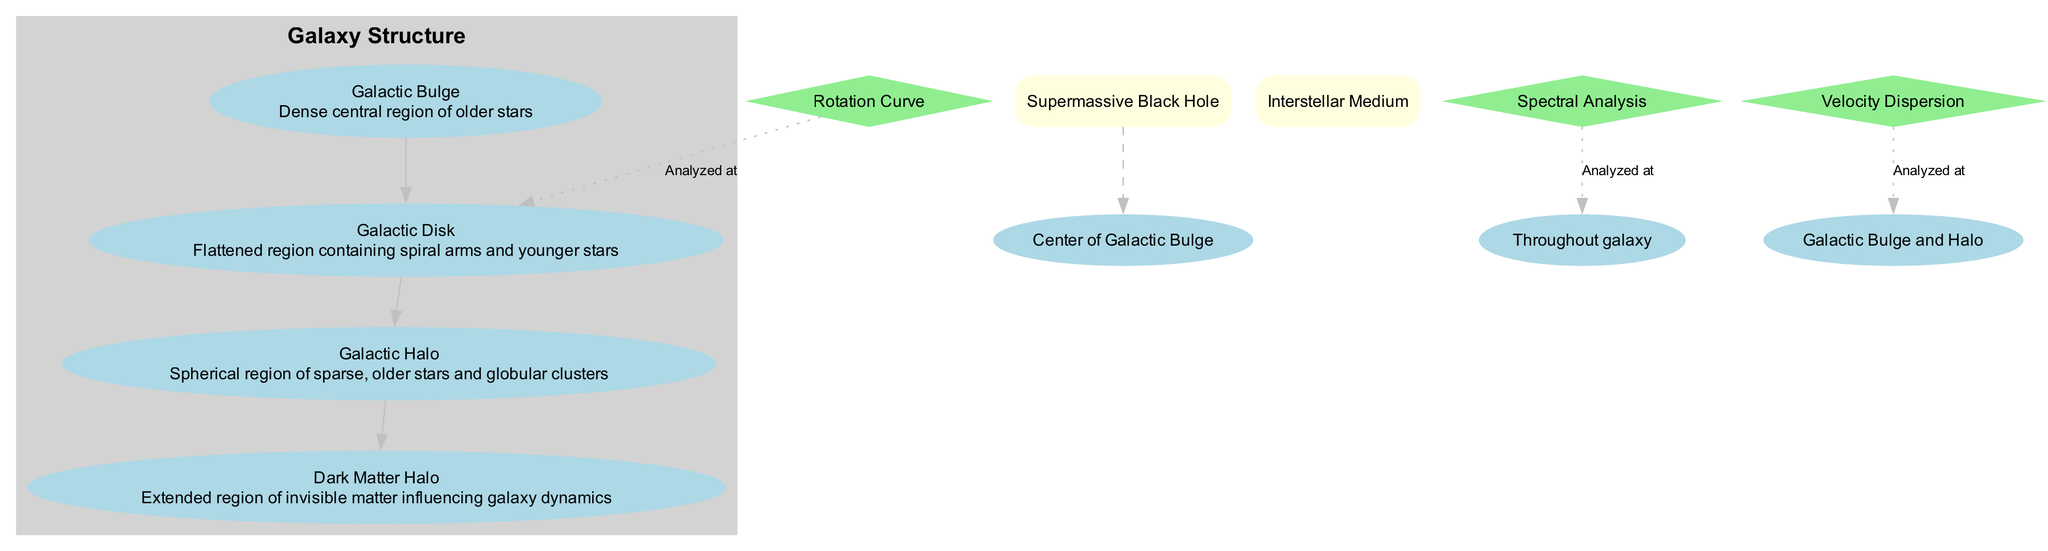What is the central region of the galaxy called? The diagram clearly labels the "Galactic Bulge" as the central region of the galaxy. This is where the majority of the older stars are located.
Answer: Galactic Bulge How many main components are depicted in the diagram? The main components listed include the Galactic Bulge, Galactic Disk, Galactic Halo, and Dark Matter Halo. There are four components total based on the subgraph structure.
Answer: 4 Which feature is located at the center of the Galactic Bulge? The diagram indicates that a "Supermassive Black Hole" is located at the center of the Galactic Bulge. This relationship is established by the specific location noted in the diagram.
Answer: Supermassive Black Hole What connects the Galactic Disk to the Galactic Halo? The edge (or connection) is represented by the arrow pointing from the Galactic Disk to the Galactic Halo in the diagram. This indicates a direct relationship between these two main components.
Answer: Galactic Disk Where is the Interstellar Medium distributed throughout the galaxy? The Interstellar Medium is described in the diagram as being distributed throughout the galaxy, which indicates its pervasive presence across various regions, including the Bulge, Disk, and Halo.
Answer: Throughout the galaxy What type of analysis is indicated in the Galactic Disk? The diagram shows that the "Rotation Curve" analysis is specifically located in the Galactic Disk, highlighted by a dotted line leading to the corresponding point.
Answer: Rotation Curve Which component is associated with sparse, older stars? The "Galactic Halo" is defined in the diagram as the spherical region containing sparse, older stars. This information is contained in the description of the Galactic Halo.
Answer: Galactic Halo What is the relationship between the Galactic Halo and Dark Matter Halo? The diagram connects the Galactic Halo to the Dark Matter Halo, indicating that the Galactic Halo transitions into this extended invisible region of matter that influences dynamics.
Answer: Galactic Halo What kind of matter influences galaxy dynamics? The diagram specifies "Dark Matter Halo" as the region of invisible matter that influences galaxy dynamics, directly establishing the connection between the two concepts.
Answer: Dark Matter Halo 